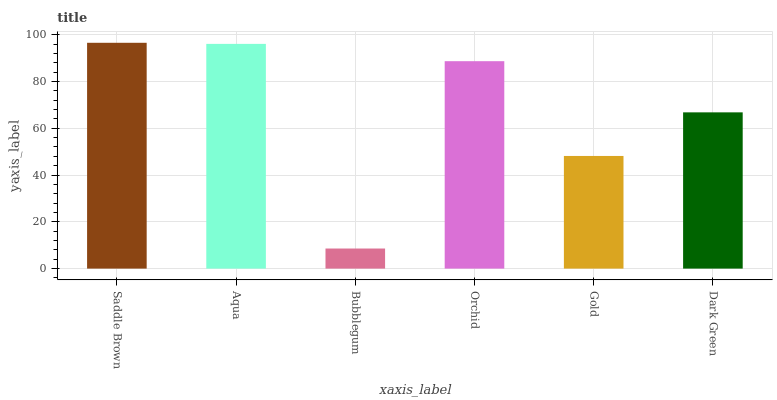Is Bubblegum the minimum?
Answer yes or no. Yes. Is Saddle Brown the maximum?
Answer yes or no. Yes. Is Aqua the minimum?
Answer yes or no. No. Is Aqua the maximum?
Answer yes or no. No. Is Saddle Brown greater than Aqua?
Answer yes or no. Yes. Is Aqua less than Saddle Brown?
Answer yes or no. Yes. Is Aqua greater than Saddle Brown?
Answer yes or no. No. Is Saddle Brown less than Aqua?
Answer yes or no. No. Is Orchid the high median?
Answer yes or no. Yes. Is Dark Green the low median?
Answer yes or no. Yes. Is Dark Green the high median?
Answer yes or no. No. Is Aqua the low median?
Answer yes or no. No. 